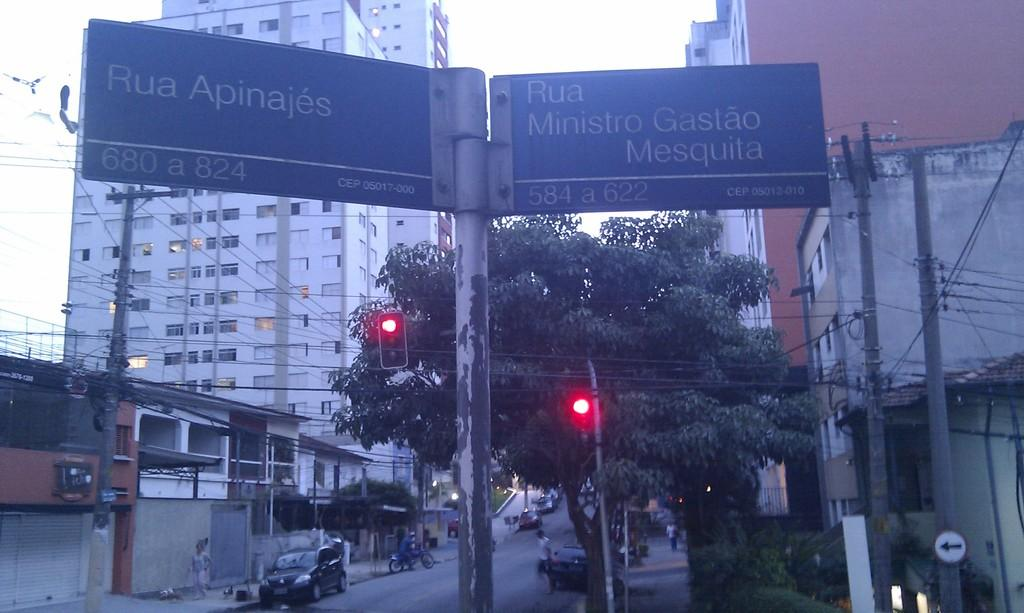<image>
Share a concise interpretation of the image provided. the word RUA at the top of a sign 